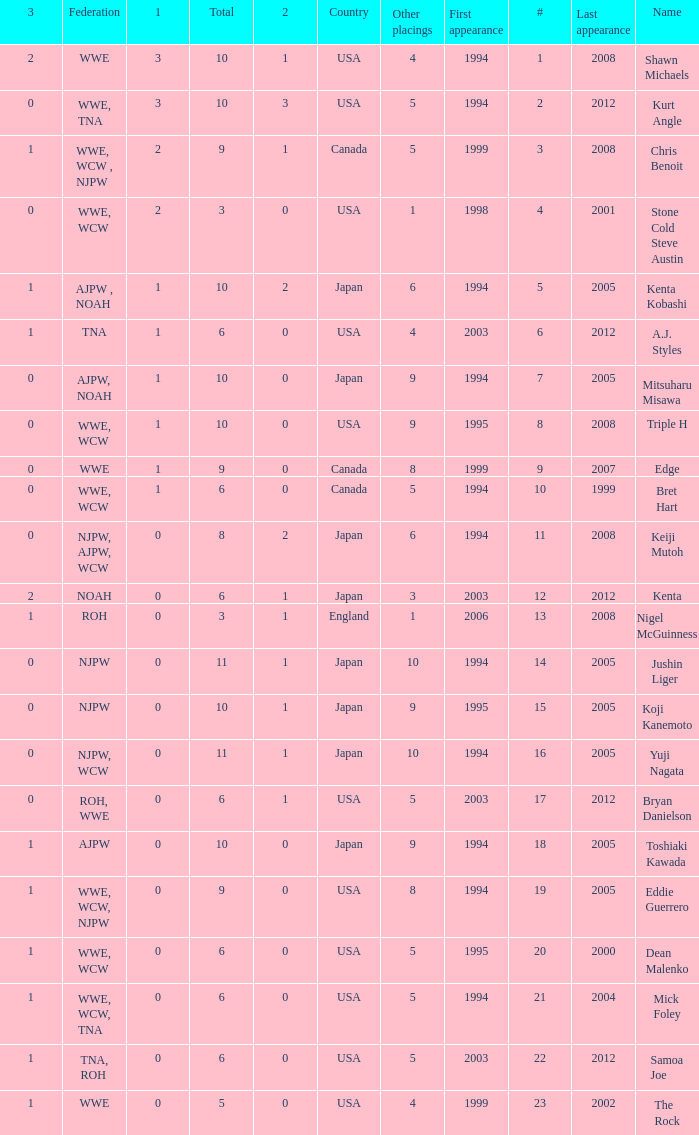How many times has a wrestler whose federation was roh, wwe competed in this event? 1.0. 